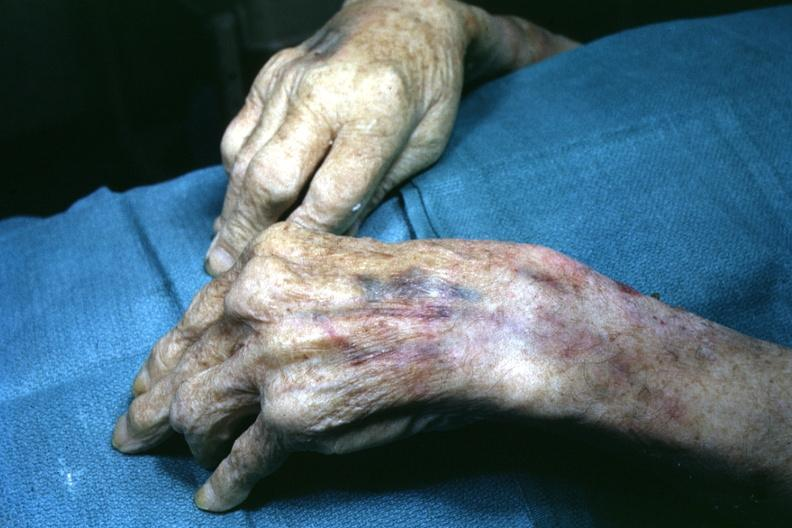does dysplastic show view of both hand with enlarged joints?
Answer the question using a single word or phrase. No 